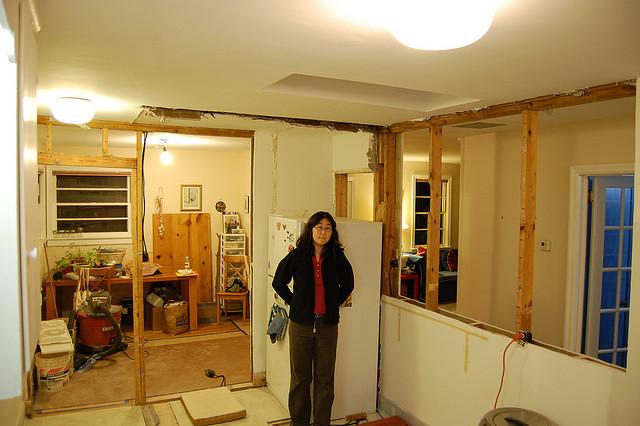What room is pictured in the apartment?
Concise answer only. Kitchen. Who is standing against the refrigerator?
Keep it brief. Woman. How many lights are there?
Keep it brief. 3. 